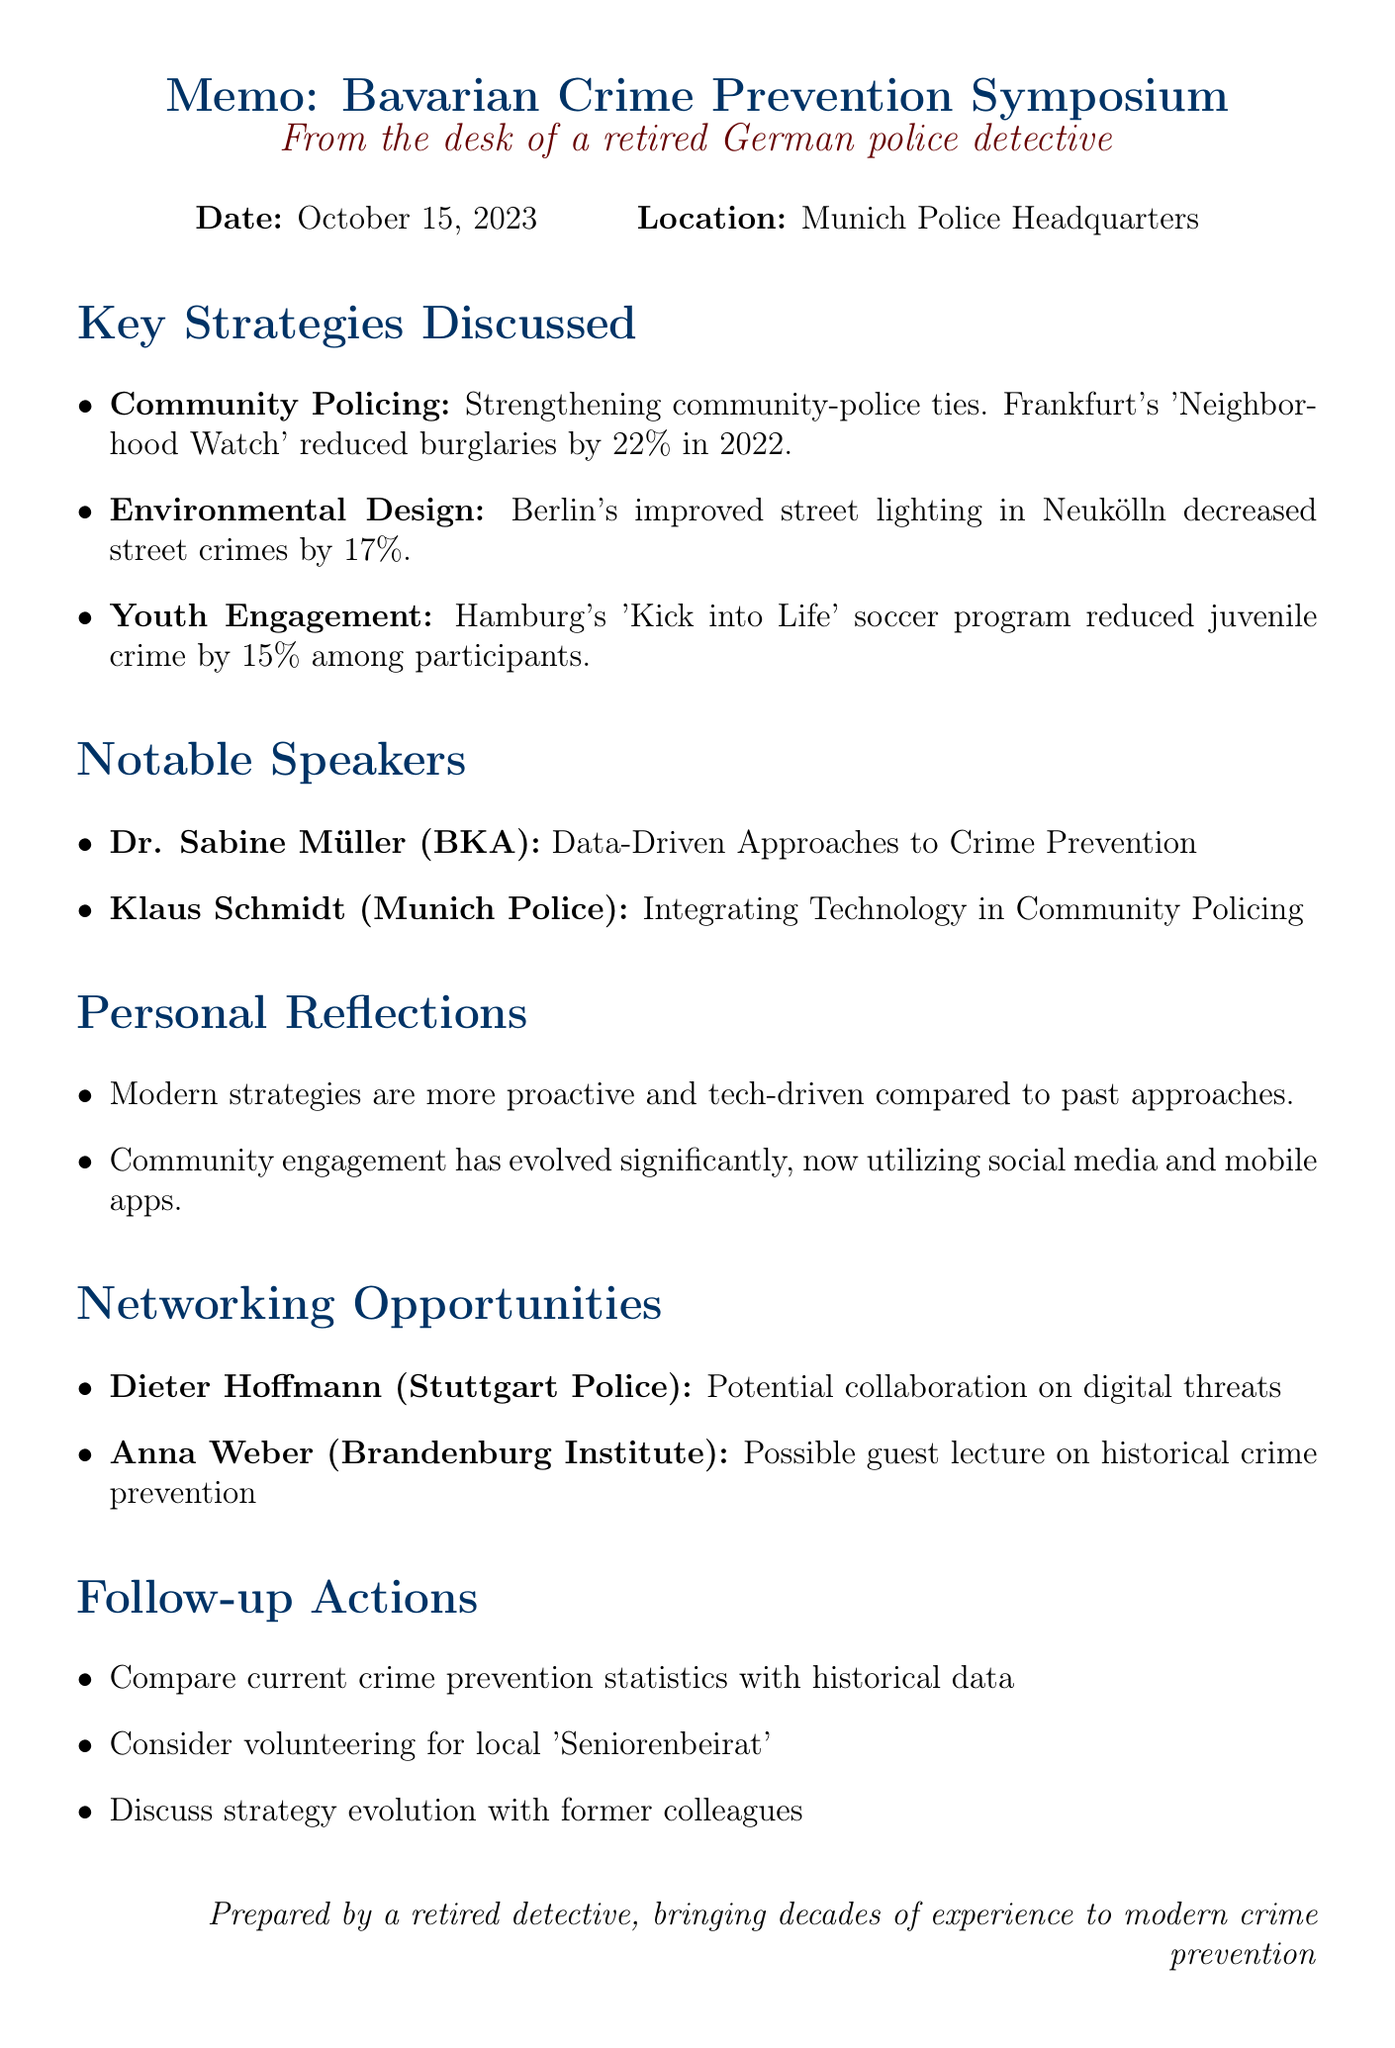What was the date of the seminar? The date of the seminar is explicitly mentioned in the document.
Answer: October 15, 2023 Who organized the Bavarian Crime Prevention Symposium? The document states the organizer of the event.
Answer: Bavarian State Office of Criminal Investigation What was the reduction percentage in burglaries due to the Neighborhood Watch program? This specific statistic is provided in the section discussing effective strategies.
Answer: 22% Who was the keynote speaker discussing data-driven approaches? The document includes the names and topics of the speakers.
Answer: Dr. Sabine Müller Which strategy mentioned aimed at involving at-risk youth? The effective strategies section gives examples of various strategies.
Answer: Youth Engagement Programs What is a follow-up action suggested in the memo? The follow-up actions are listed, showing possible next steps after the seminar.
Answer: Review and compare current crime prevention statistics What type of technology was discussed by Klaus Schmidt? Klaus Schmidt's topic relates to a specific aspect of policing, as per the document.
Answer: Integrating Technology Which city had a 17% decrease in street crimes due to improved street lighting? This information is found in the section on effective strategies.
Answer: Berlin 